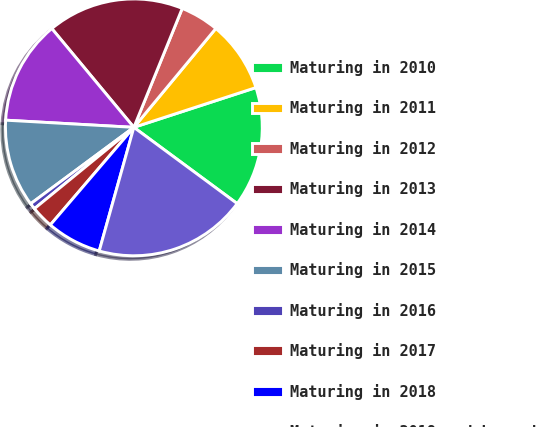<chart> <loc_0><loc_0><loc_500><loc_500><pie_chart><fcel>Maturing in 2010<fcel>Maturing in 2011<fcel>Maturing in 2012<fcel>Maturing in 2013<fcel>Maturing in 2014<fcel>Maturing in 2015<fcel>Maturing in 2016<fcel>Maturing in 2017<fcel>Maturing in 2018<fcel>Maturing in 2019 and beyond<nl><fcel>15.13%<fcel>8.97%<fcel>4.87%<fcel>17.18%<fcel>13.08%<fcel>11.03%<fcel>0.77%<fcel>2.82%<fcel>6.92%<fcel>19.23%<nl></chart> 